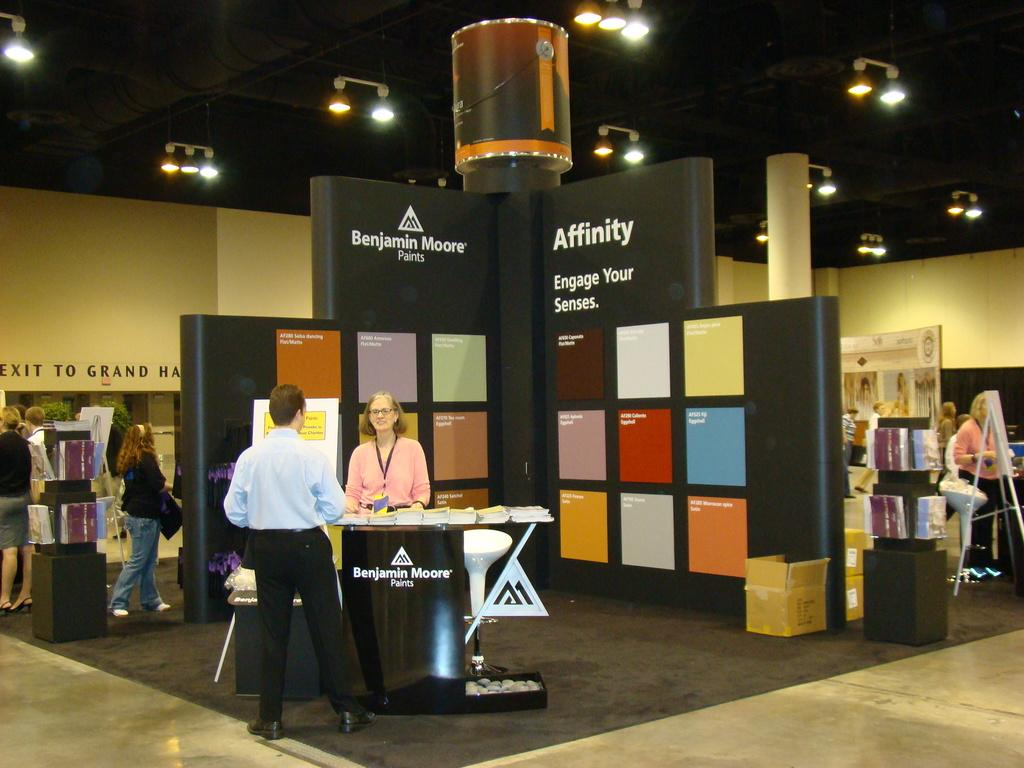How many people are present in the image? There are many people in the image. What is the purpose of the podium in the image? The podium is likely used for speeches or presentations. What is the chair used for in the image? The chair is likely used by the speaker or presenter. What is the purpose of the lights above the podium and chair? The lights provide illumination for the speaker or presenter. What object is also present in the image? There is a box in the image. What type of smell can be detected from the kitten on the farm in the image? There is no kitten or farm present in the image. How many cows are visible on the farm in the image? There is no farm or cows present in the image. 